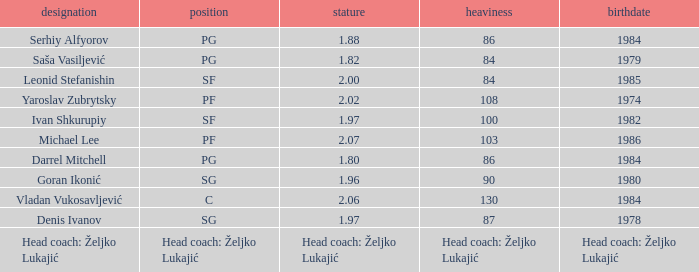What is the weight of the person born in 1980? 90.0. 